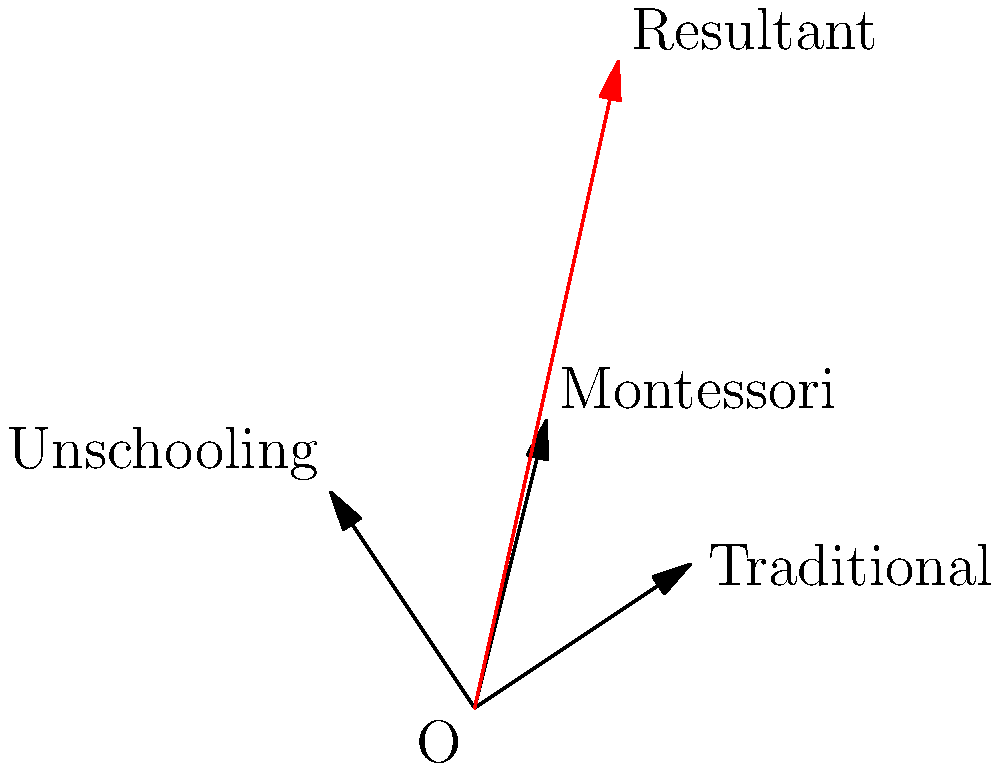In an educational conference, different approaches are represented as vectors. Traditional education is represented by vector $\vec{a} = 3\hat{i} + 2\hat{j}$, Montessori by $\vec{b} = \hat{i} + 4\hat{j}$, and Unschooling by $\vec{c} = -2\hat{i} + 3\hat{j}$. Calculate the magnitude of the resultant vector representing the combined impact of these approaches. To solve this problem, we'll follow these steps:

1) First, we need to find the resultant vector by adding the three given vectors:
   $\vec{r} = \vec{a} + \vec{b} + \vec{c}$

2) Let's add the components:
   $\vec{r} = (3+1-2)\hat{i} + (2+4+3)\hat{j}$
   $\vec{r} = 2\hat{i} + 9\hat{j}$

3) Now that we have the resultant vector, we can calculate its magnitude using the Pythagorean theorem:
   $|\vec{r}| = \sqrt{x^2 + y^2}$, where $x$ and $y$ are the components of $\vec{r}$

4) Substituting the values:
   $|\vec{r}| = \sqrt{2^2 + 9^2}$

5) Simplifying:
   $|\vec{r}| = \sqrt{4 + 81} = \sqrt{85}$

Therefore, the magnitude of the resultant vector is $\sqrt{85}$ units.
Answer: $\sqrt{85}$ units 